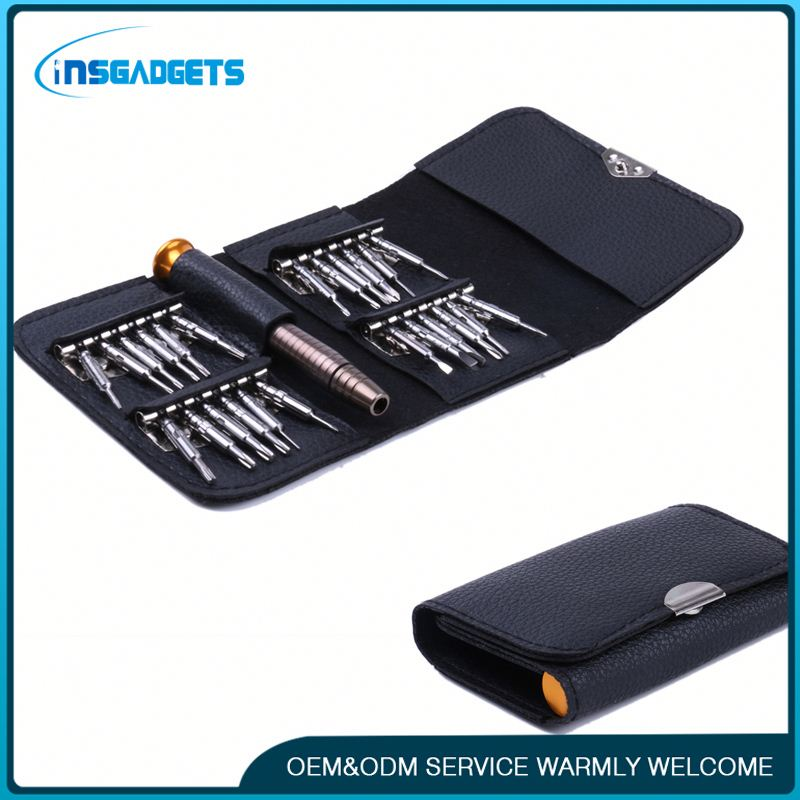Imagine you are narrating an advertisement featuring this tool kit. What would you say? Introducing the INSGADGETS Precision Screwdriver Set! Whether you're tackling small repairs at home, working on detailed projects, or need reliable tools for professional use, this set has you covered. Compact and organized, it includes a variety of interchangeable bits to meet all your precision needs. The durable, sleek case ensures everything stays in place, ready for your next project. Plus, with our OEM & ODM services, we warmly welcome you to customize your tools with us. Trust INSGADGETS for all your precision tool requirements—where quality meets innovation. What does OEM & ODM stand for and what do these services entail? OEM stands for Original Equipment Manufacturer, while ODM stands for Original Design Manufacturer. OEM services involve producing equipment or components that are purchased by another company and retailed under that purchasing company's brand name. On the other hand, ODM services refer to companies that design and manufacture a product as specified, which is then branded by another firm to be sold. These services are beneficial for businesses looking for customized products without investing in the manufacturing capabilities themselves. INSGADGETS offers both, providing flexibility and customization to meet diverse client needs. Tell me a creative story about how this tool set could be used in an adventurous scenario. In the heart of a dense jungle, an explorer named Alex found an ancient temple hidden beneath the foliage. As Alex navigated the labyrinthine chambers, he encountered a puzzling mechanism guarding a long-lost artifact. With no room for error and buzzing traps ready to spring, Alex reached for the INSGADGETS Precision Screwdriver Set. Each bit chosen with care, Alex deftly dismantled complex gears and rerouted wires, slowly unlocking the temple's secrets. The precisely crafted tools turned mechanical mysteries into a playground of exploration. Finally, the last screw gave way, and the artifact was within reach—a treasure unlocking the mysteries of a bygone civilization—all thanks to a reliable set of precision tools. 